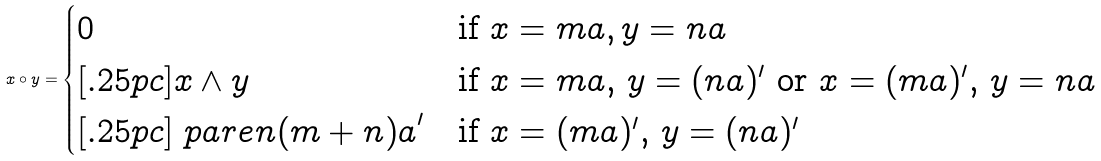<formula> <loc_0><loc_0><loc_500><loc_500>x \circ y = \begin{cases} 0 & \text {if $x=ma, y=na$} \\ [ . 2 5 p c ] x \wedge y & \text {if $x=ma$, $y=(na)^{\prime}$ or $x=(ma)^{\prime}$, $y=na$} \\ [ . 2 5 p c ] \ p a r e n { ( m + n ) a } ^ { \prime } & \text {if $x=(ma)^{\prime}$, $y=(na)^{\prime}$} \end{cases}</formula> 